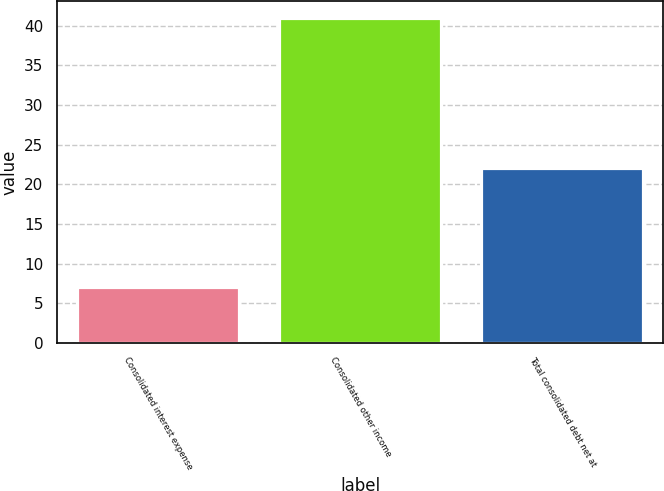<chart> <loc_0><loc_0><loc_500><loc_500><bar_chart><fcel>Consolidated interest expense<fcel>Consolidated other income<fcel>Total consolidated debt net at<nl><fcel>7<fcel>41<fcel>22<nl></chart> 